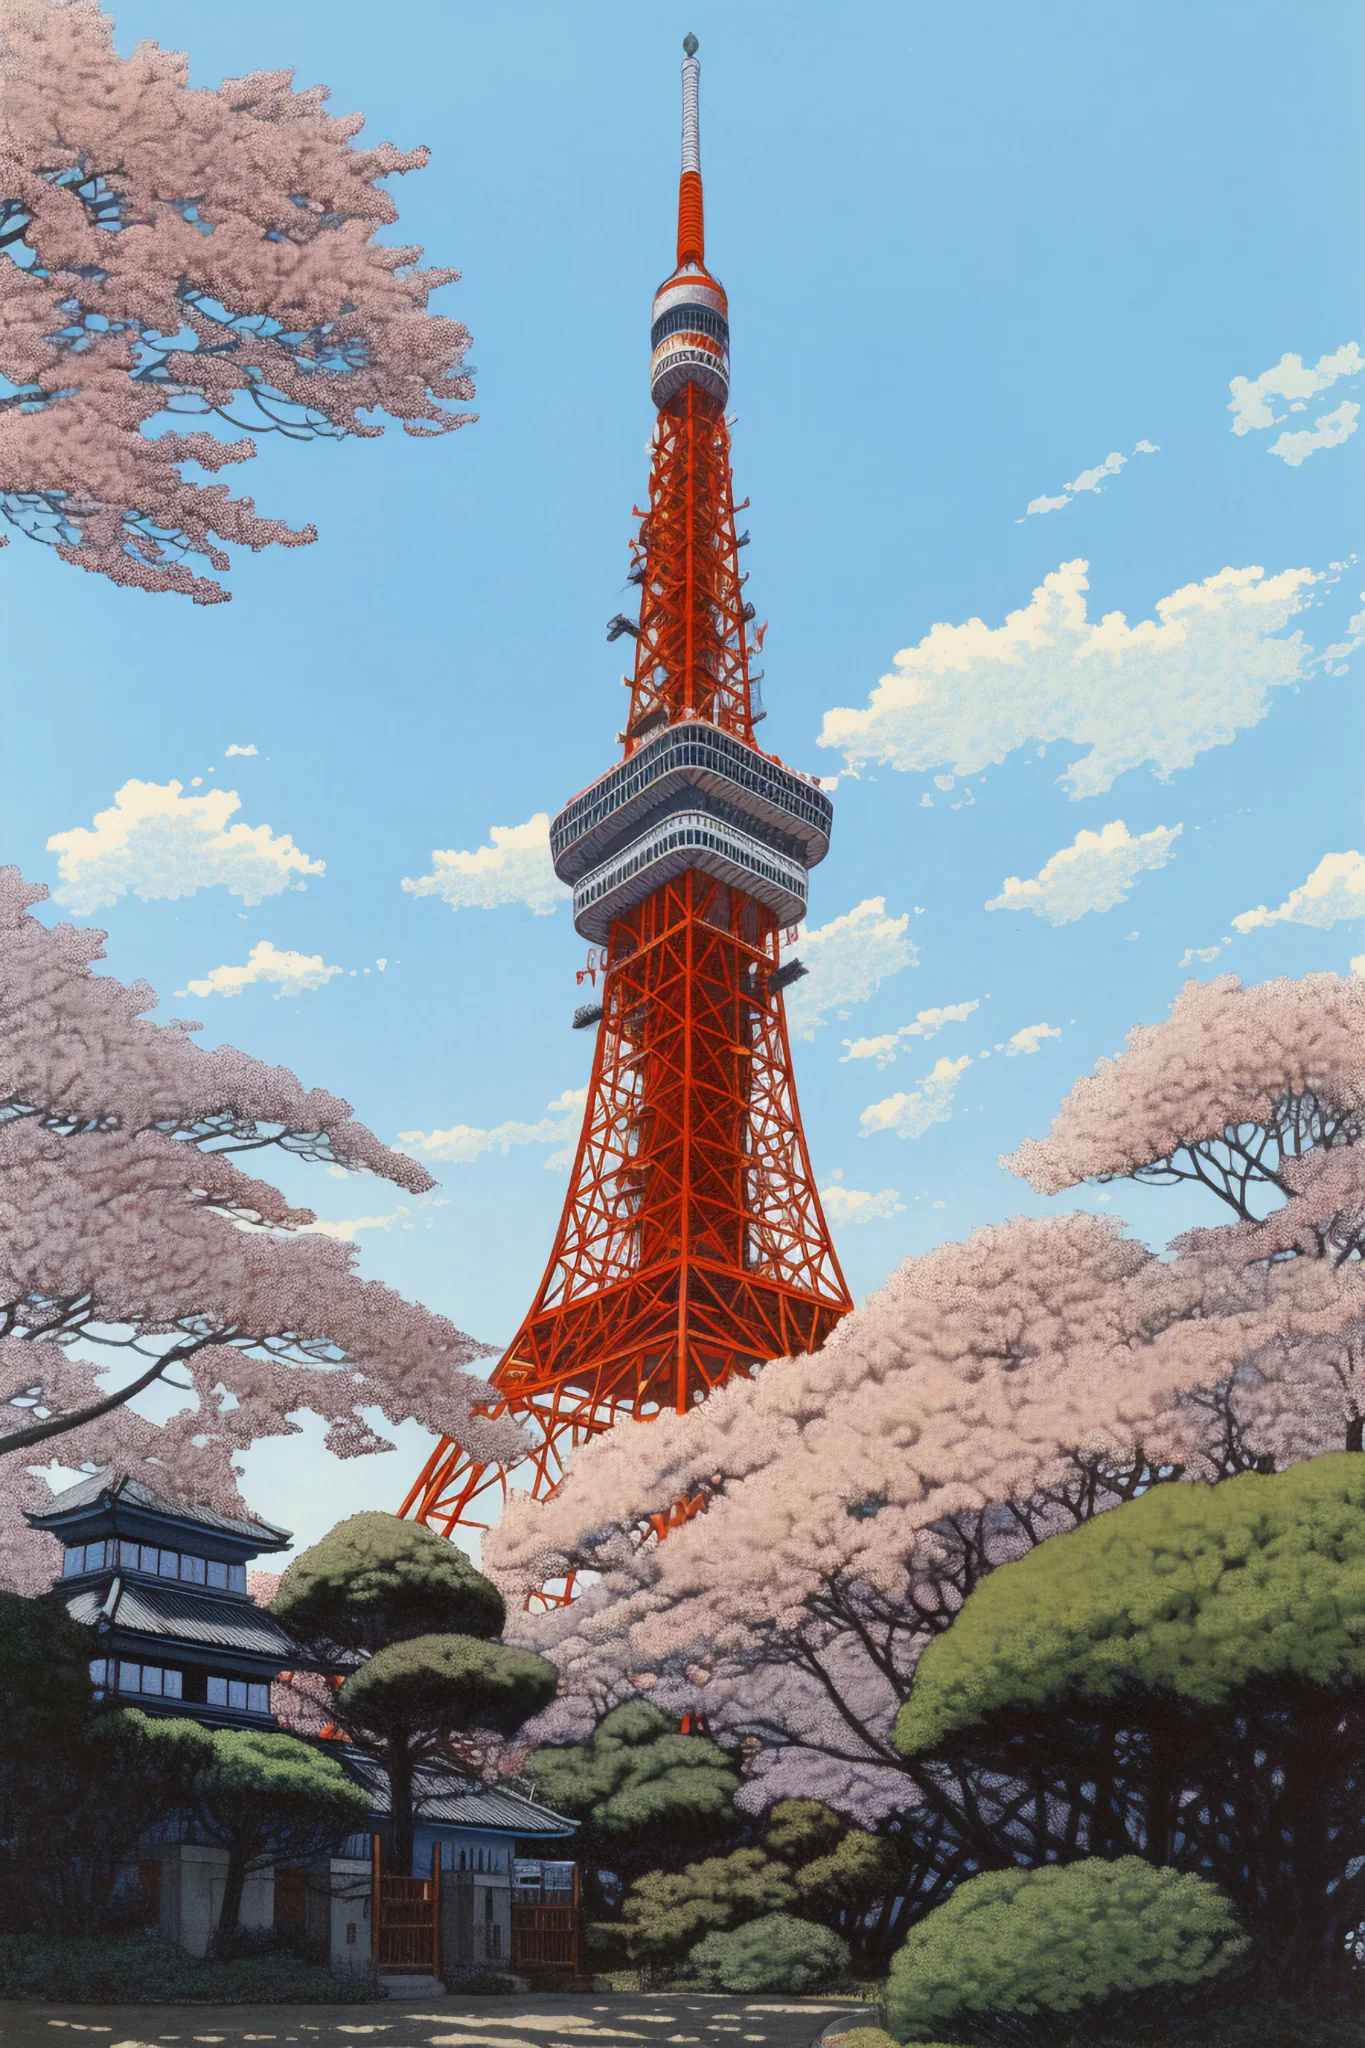Imagine the Tokyo Tower is a character in an animated film. What kind of narrative could be woven around it? In an animated film, Tokyo Tower could be an ancient guardian of the city, imbued with magical powers that awaken only once every century to protect Tokyo from impending threats. The story could follow a young protagonist who discovers the tower's hidden secrets and forms an unlikely alliance with it. Together, they embark on a thrilling adventure through past and present Tokyo, facing mystical creatures and uncovering forgotten histories. The tower, with its towering presence and deep-rooted connection to the city's lore, becomes both a majestic sentinel and a wise guide, teaching lessons of resilience, unity, and history. 